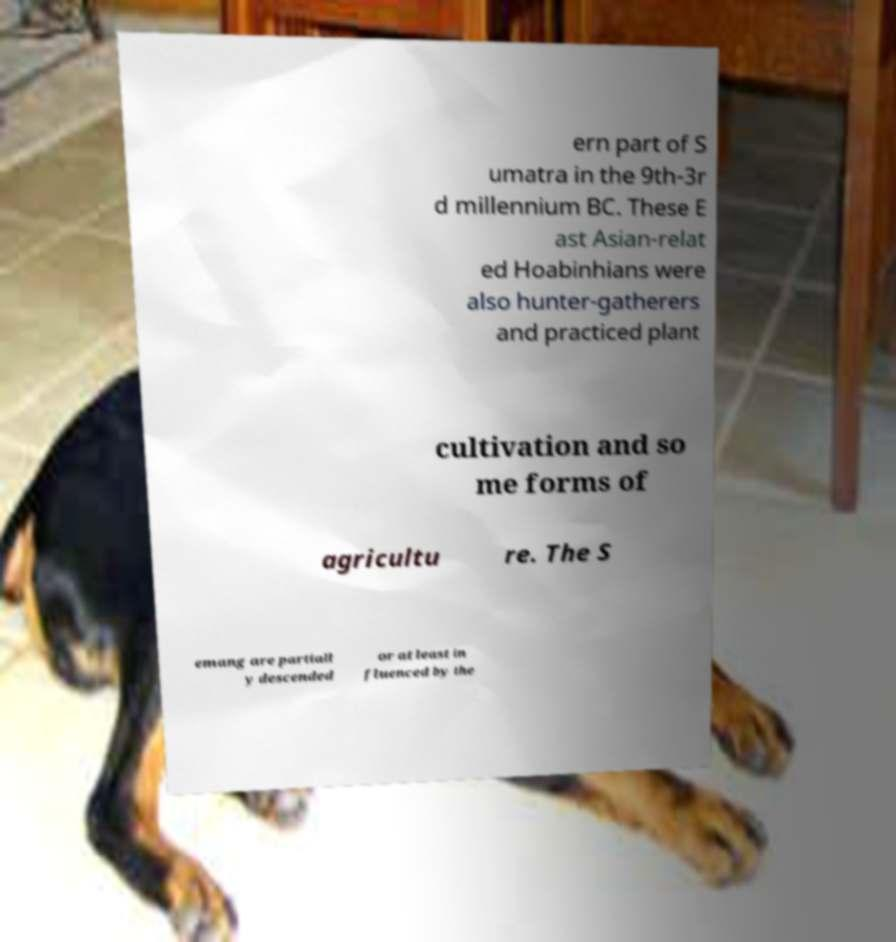What messages or text are displayed in this image? I need them in a readable, typed format. ern part of S umatra in the 9th-3r d millennium BC. These E ast Asian-relat ed Hoabinhians were also hunter-gatherers and practiced plant cultivation and so me forms of agricultu re. The S emang are partiall y descended or at least in fluenced by the 